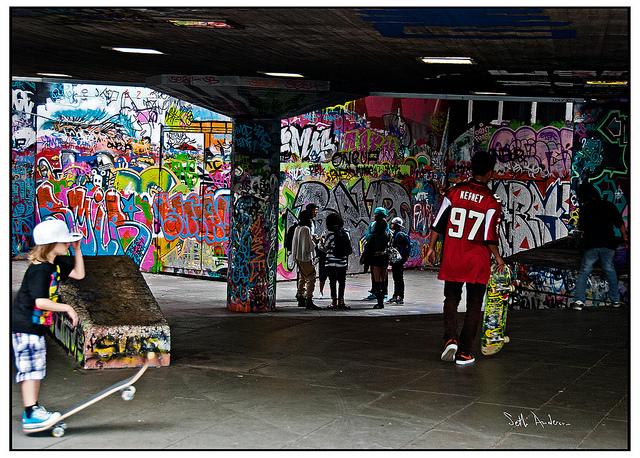Is there graffiti on the walls?
Quick response, please. Yes. What color are the shoes of the boy in front with the white hat?
Concise answer only. Blue. How many wheels are on the skateboard?
Quick response, please. 4. 